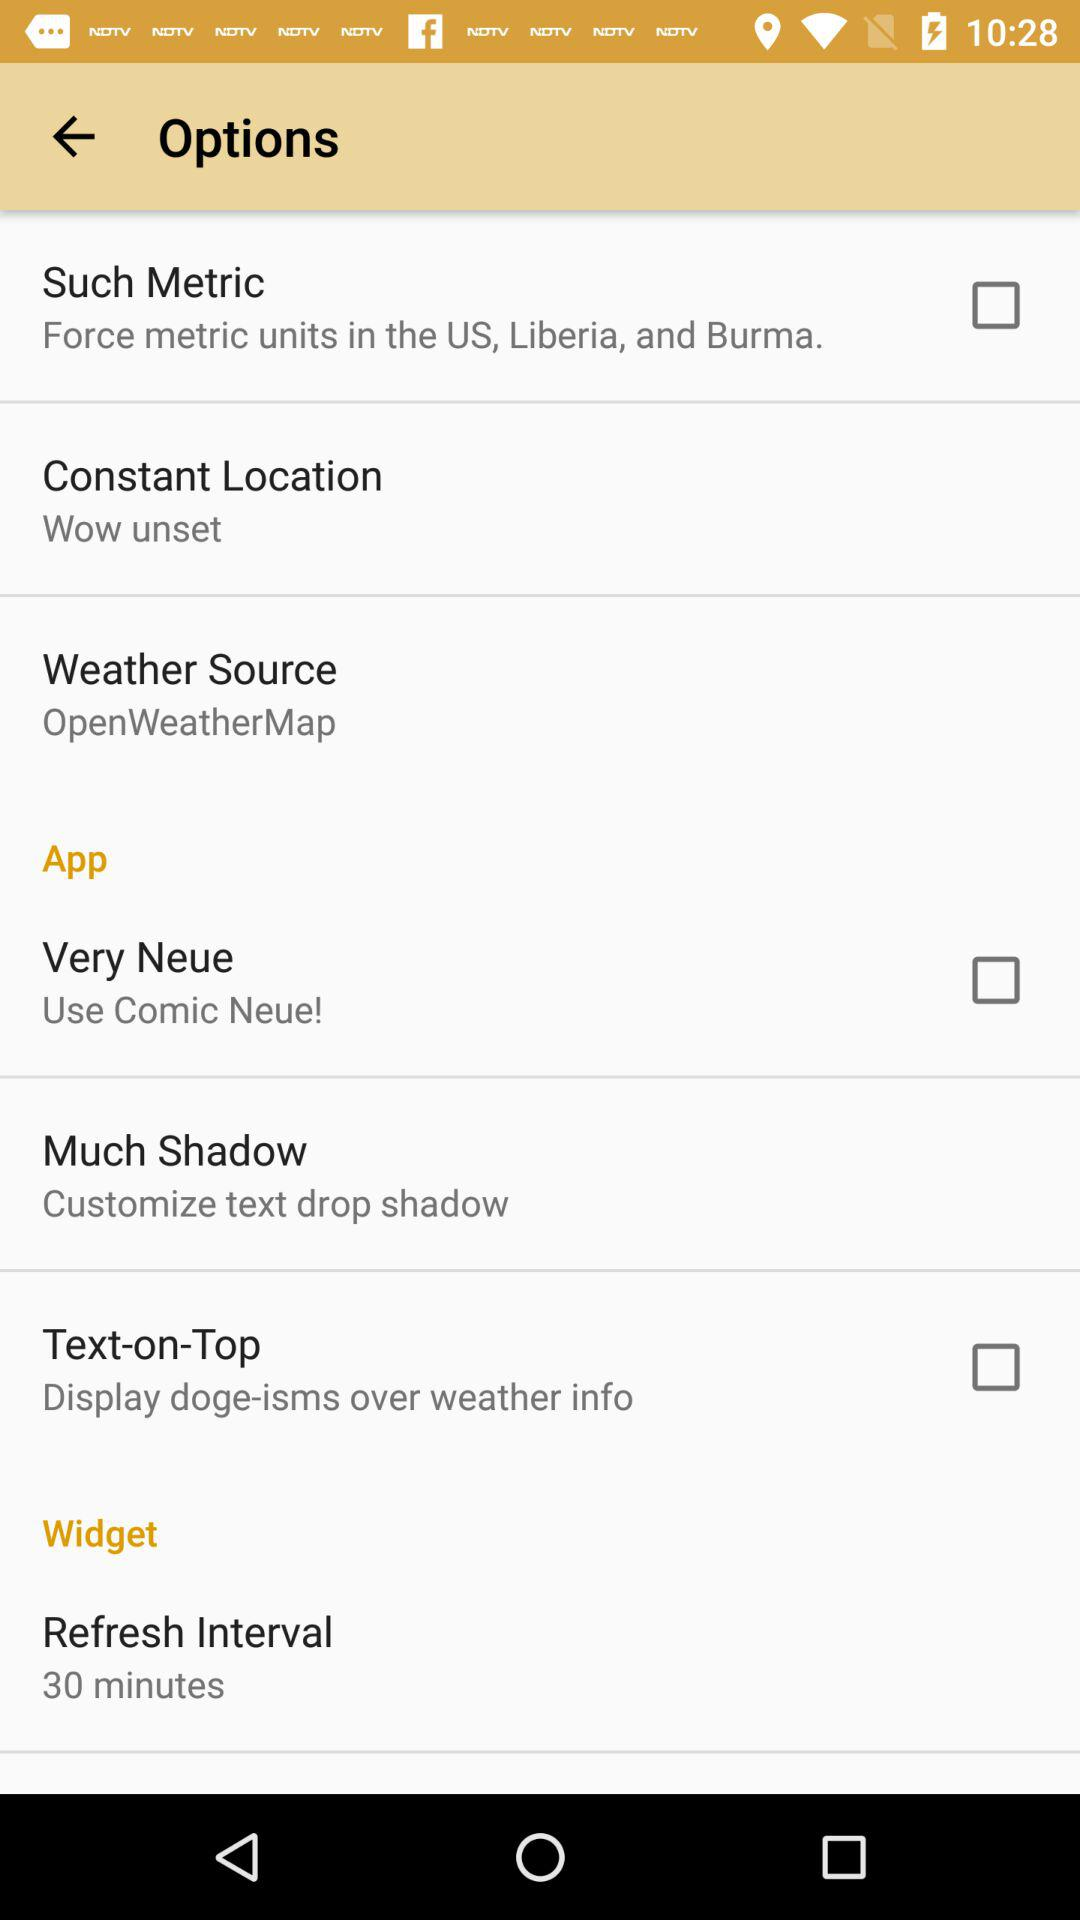What is the status of "Such Metric"? The status is "off". 